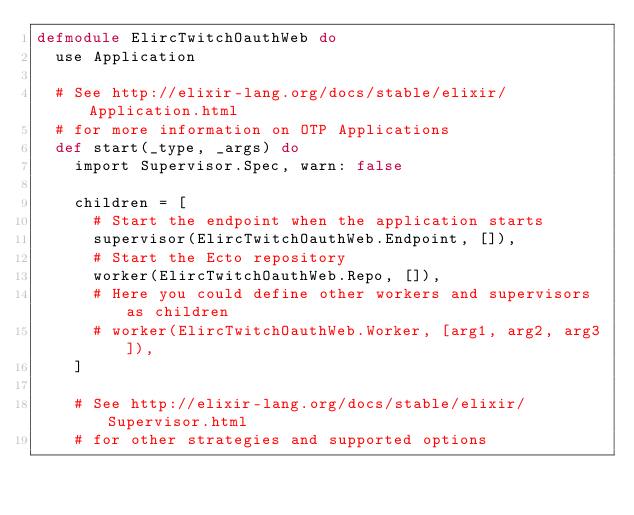<code> <loc_0><loc_0><loc_500><loc_500><_Elixir_>defmodule ElircTwitchOauthWeb do
  use Application

  # See http://elixir-lang.org/docs/stable/elixir/Application.html
  # for more information on OTP Applications
  def start(_type, _args) do
    import Supervisor.Spec, warn: false

    children = [
      # Start the endpoint when the application starts
      supervisor(ElircTwitchOauthWeb.Endpoint, []),
      # Start the Ecto repository
      worker(ElircTwitchOauthWeb.Repo, []),
      # Here you could define other workers and supervisors as children
      # worker(ElircTwitchOauthWeb.Worker, [arg1, arg2, arg3]),
    ]

    # See http://elixir-lang.org/docs/stable/elixir/Supervisor.html
    # for other strategies and supported options</code> 